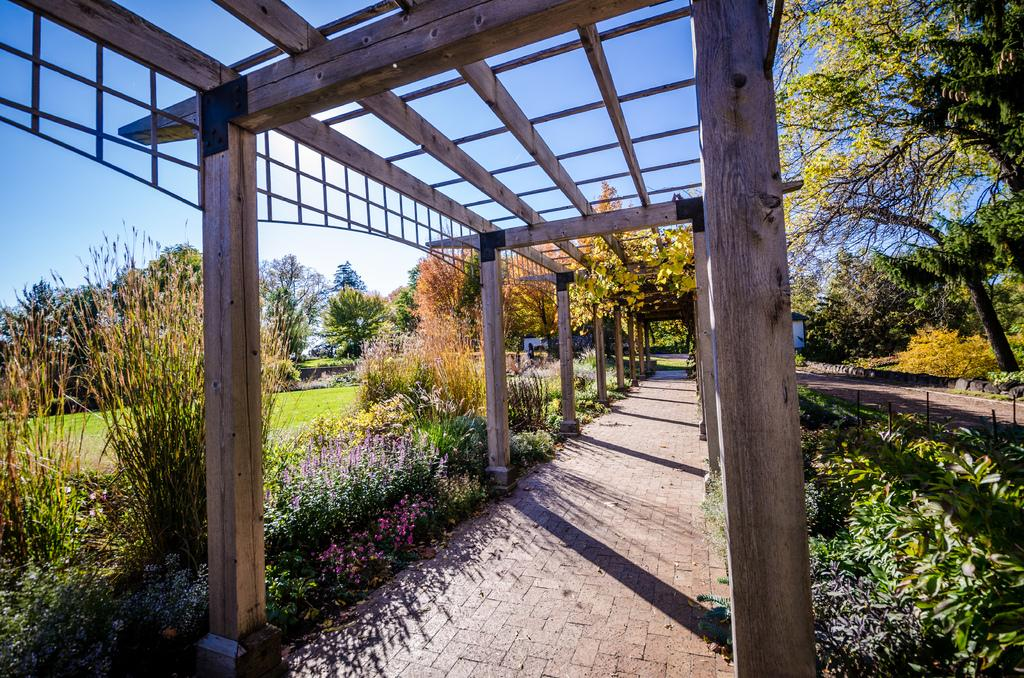What type of structures can be seen in the image? There are wooden poles in the image. What can be used for walking or traveling in the image? There are paths in the image. What type of vegetation is present in the image? There are plants, grass, and trees in the image. What other objects can be seen in the image? There are some objects in the image. What is visible in the background of the image? The sky is visible in the background of the image. Reasoning: Let' Let's think step by step in order to produce the conversation. We start by identifying the main structures and objects in the image based on the provided facts. We then formulate questions that focus on the characteristics and functions of these structures and objects, ensuring that each question can be answered definitively with the information given. We avoid yes/no questions and ensure that the language is simple and clear. Absurd Question/Answer: What type of advice can be seen written on the wooden poles in the image? There is no advice written on the wooden poles in the image; they are simply structures. What type of leg can be seen in the image? There is no leg present in the image; it features wooden poles, paths, plants, grass, trees, and objects. What type of stew can be seen simmering in the background of the image? There is no stew present in the image; it features wooden poles, paths, plants, grass, trees, and objects. 